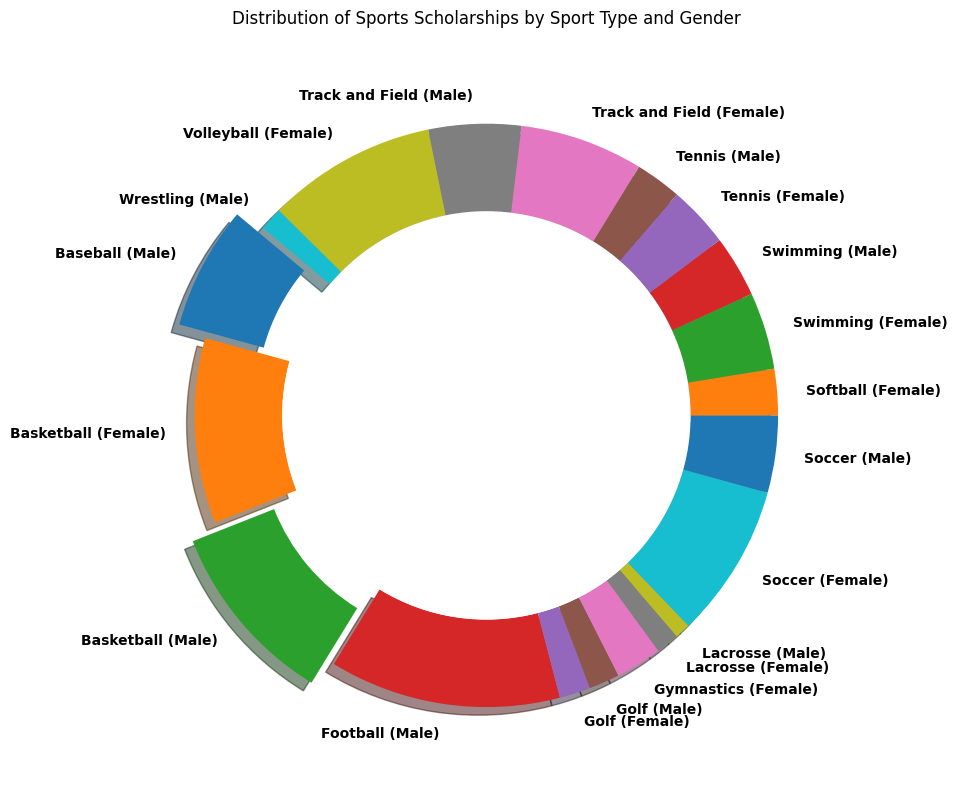Which sport type receives the highest number of scholarships for males? The ring chart shows "Football (Male)" with the largest wedge. Therefore, football receives the highest number of scholarships for males.
Answer: Football Which sport type has fewer scholarships for females, swimming or softball? The ring chart shows both "Swimming (Female)" and "Softball (Female)" labels, but "Swimming (Female)" has a larger wedge compared to "Softball (Female)". Hence, softball has fewer scholarships for females.
Answer: Softball What's the total number of scholarships awarded to both male and female basketball players? By observing the wedges labeled "Basketball (Male)" and "Basketball (Female)", the chart shows that each gender receives 1200 scholarships. The total is 1200 + 1200 = 2400.
Answer: 2400 Determine the difference in the number of scholarships between male baseball and female soccer players. The ring chart shows "Baseball (Male)" with 800 scholarships and "Soccer (Female)" with 1000 scholarships. The difference is 1000 - 800 = 200.
Answer: 200 Which sport receives exactly 400 scholarships for males? The ring chart shows a label "Swimming (Male)" with a wedge corresponding to 400 scholarships, thus swimming receives 400 scholarships for males.
Answer: Swimming Do female tennis players receive more scholarships than male tennis players? Observation shows "Tennis (Female)" and "Tennis (Male)" wedges, each labeled with 400 scholarships, indicating they receive an equal number of scholarships.
Answer: No What is the average number of scholarships awarded for male and female track and field athletes combined? The wedges marked "Track and Field (Male)" and "Track and Field (Female)" contribute 600 and 800 scholarships respectively. The combined total is 600+800=1400, thus the average is 1400/2=700.
Answer: 700 By how much do female volleyball scholarships exceed female gymnastics scholarships? The chart shows that "Volleyball (Female)" has 1100 scholarships and "Gymnastics (Female)" has 300 scholarships. The difference is 1100 - 300 = 800.
Answer: 800 Is there any sport where male and female athletes receive an equal number of scholarships? By examining the wedges for all sport types, only "Tennis (Male)" and "Tennis (Female)" both have 400 scholarships, implying equality.
Answer: Yes 